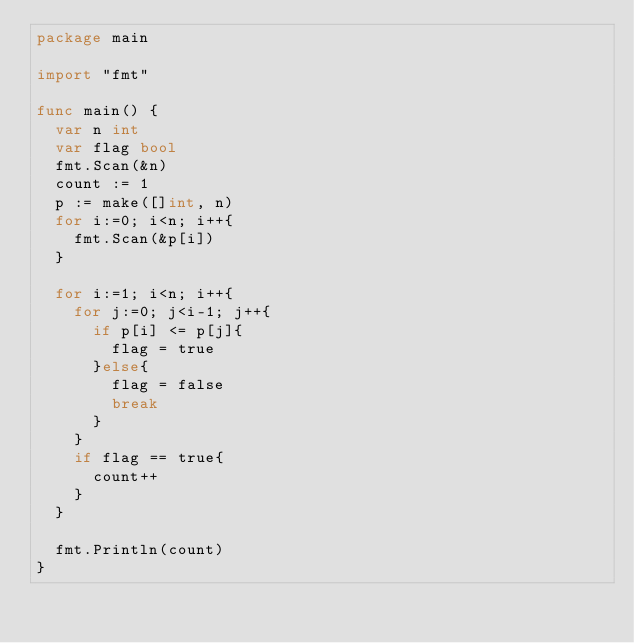<code> <loc_0><loc_0><loc_500><loc_500><_Go_>package main

import "fmt"

func main() {
	var n int
	var flag bool
	fmt.Scan(&n)
	count := 1
	p := make([]int, n)
	for i:=0; i<n; i++{
		fmt.Scan(&p[i])
	}

	for i:=1; i<n; i++{
		for j:=0; j<i-1; j++{
			if p[i] <= p[j]{
				flag = true
			}else{
				flag = false
				break
			}
		}
		if flag == true{
			count++
		}
	}

	fmt.Println(count)
}</code> 